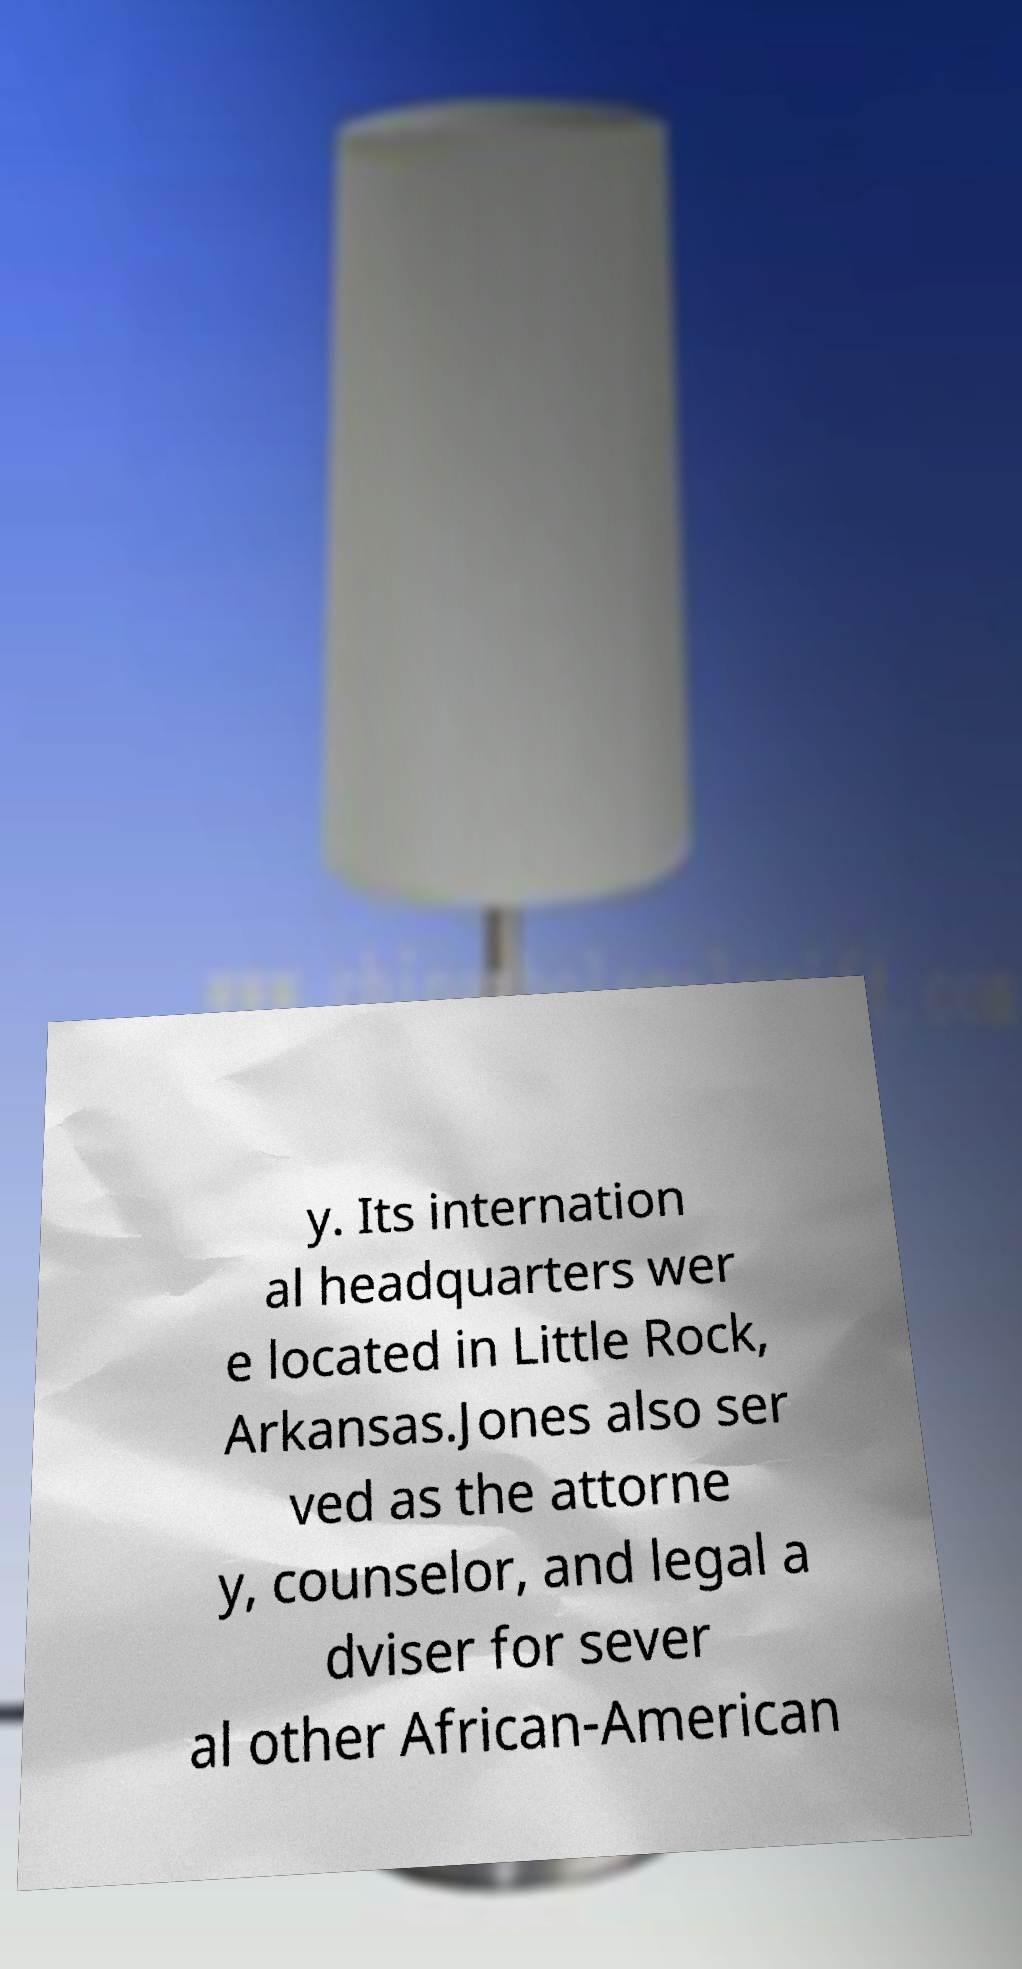Could you assist in decoding the text presented in this image and type it out clearly? y. Its internation al headquarters wer e located in Little Rock, Arkansas.Jones also ser ved as the attorne y, counselor, and legal a dviser for sever al other African-American 